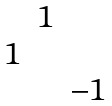<formula> <loc_0><loc_0><loc_500><loc_500>\begin{matrix} & 1 & \\ 1 & & \\ & & - 1 \end{matrix}</formula> 